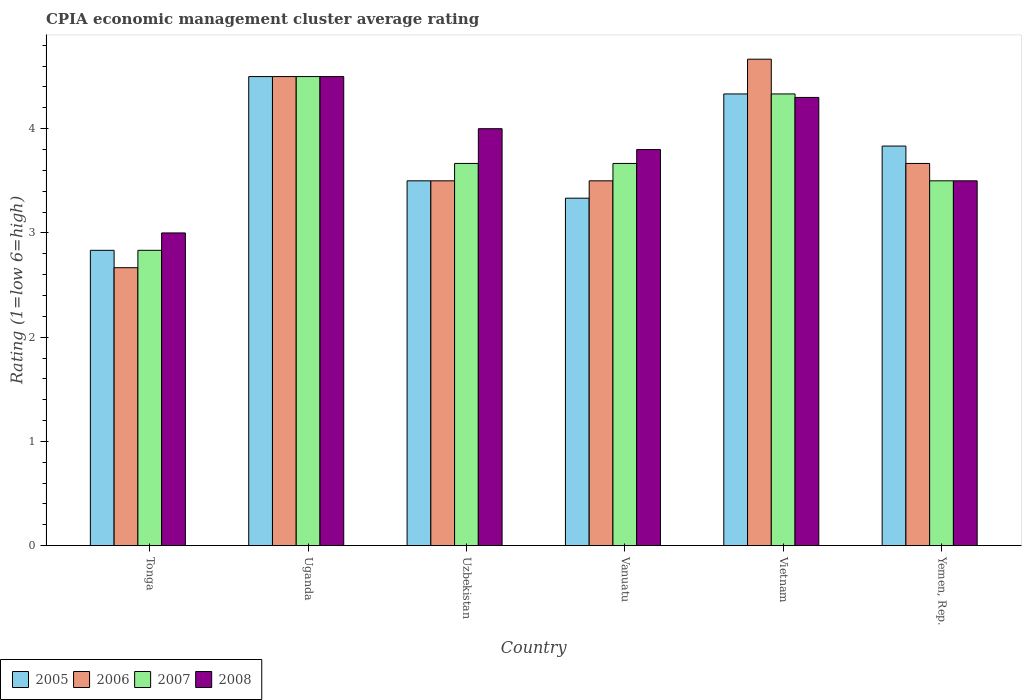How many different coloured bars are there?
Provide a short and direct response. 4. How many bars are there on the 5th tick from the left?
Ensure brevity in your answer.  4. What is the label of the 2nd group of bars from the left?
Provide a short and direct response. Uganda. In how many cases, is the number of bars for a given country not equal to the number of legend labels?
Keep it short and to the point. 0. What is the CPIA rating in 2006 in Tonga?
Ensure brevity in your answer.  2.67. Across all countries, what is the maximum CPIA rating in 2007?
Your answer should be compact. 4.5. Across all countries, what is the minimum CPIA rating in 2006?
Provide a short and direct response. 2.67. In which country was the CPIA rating in 2005 maximum?
Your answer should be compact. Uganda. In which country was the CPIA rating in 2006 minimum?
Keep it short and to the point. Tonga. What is the total CPIA rating in 2006 in the graph?
Your answer should be compact. 22.5. What is the difference between the CPIA rating in 2006 in Uzbekistan and that in Vietnam?
Keep it short and to the point. -1.17. What is the difference between the CPIA rating in 2008 in Vanuatu and the CPIA rating in 2006 in Yemen, Rep.?
Make the answer very short. 0.13. What is the average CPIA rating in 2008 per country?
Make the answer very short. 3.85. What is the difference between the CPIA rating of/in 2006 and CPIA rating of/in 2005 in Vietnam?
Offer a very short reply. 0.33. What is the ratio of the CPIA rating in 2008 in Tonga to that in Vietnam?
Provide a short and direct response. 0.7. Is the difference between the CPIA rating in 2006 in Tonga and Yemen, Rep. greater than the difference between the CPIA rating in 2005 in Tonga and Yemen, Rep.?
Ensure brevity in your answer.  No. In how many countries, is the CPIA rating in 2008 greater than the average CPIA rating in 2008 taken over all countries?
Ensure brevity in your answer.  3. Is it the case that in every country, the sum of the CPIA rating in 2007 and CPIA rating in 2008 is greater than the sum of CPIA rating in 2006 and CPIA rating in 2005?
Give a very brief answer. No. What does the 4th bar from the left in Vanuatu represents?
Your response must be concise. 2008. How many countries are there in the graph?
Offer a very short reply. 6. Are the values on the major ticks of Y-axis written in scientific E-notation?
Make the answer very short. No. Where does the legend appear in the graph?
Your answer should be very brief. Bottom left. How many legend labels are there?
Your response must be concise. 4. How are the legend labels stacked?
Provide a short and direct response. Horizontal. What is the title of the graph?
Provide a succinct answer. CPIA economic management cluster average rating. What is the label or title of the Y-axis?
Ensure brevity in your answer.  Rating (1=low 6=high). What is the Rating (1=low 6=high) of 2005 in Tonga?
Give a very brief answer. 2.83. What is the Rating (1=low 6=high) in 2006 in Tonga?
Your response must be concise. 2.67. What is the Rating (1=low 6=high) in 2007 in Tonga?
Make the answer very short. 2.83. What is the Rating (1=low 6=high) in 2008 in Tonga?
Offer a terse response. 3. What is the Rating (1=low 6=high) of 2006 in Uganda?
Ensure brevity in your answer.  4.5. What is the Rating (1=low 6=high) in 2007 in Uganda?
Your response must be concise. 4.5. What is the Rating (1=low 6=high) in 2007 in Uzbekistan?
Your answer should be compact. 3.67. What is the Rating (1=low 6=high) of 2008 in Uzbekistan?
Make the answer very short. 4. What is the Rating (1=low 6=high) in 2005 in Vanuatu?
Your answer should be very brief. 3.33. What is the Rating (1=low 6=high) of 2006 in Vanuatu?
Your answer should be very brief. 3.5. What is the Rating (1=low 6=high) in 2007 in Vanuatu?
Provide a short and direct response. 3.67. What is the Rating (1=low 6=high) of 2008 in Vanuatu?
Provide a succinct answer. 3.8. What is the Rating (1=low 6=high) of 2005 in Vietnam?
Your response must be concise. 4.33. What is the Rating (1=low 6=high) in 2006 in Vietnam?
Provide a succinct answer. 4.67. What is the Rating (1=low 6=high) of 2007 in Vietnam?
Your answer should be compact. 4.33. What is the Rating (1=low 6=high) of 2005 in Yemen, Rep.?
Your answer should be very brief. 3.83. What is the Rating (1=low 6=high) in 2006 in Yemen, Rep.?
Keep it short and to the point. 3.67. What is the Rating (1=low 6=high) of 2007 in Yemen, Rep.?
Provide a succinct answer. 3.5. What is the Rating (1=low 6=high) of 2008 in Yemen, Rep.?
Keep it short and to the point. 3.5. Across all countries, what is the maximum Rating (1=low 6=high) in 2005?
Offer a very short reply. 4.5. Across all countries, what is the maximum Rating (1=low 6=high) of 2006?
Make the answer very short. 4.67. Across all countries, what is the maximum Rating (1=low 6=high) in 2008?
Provide a short and direct response. 4.5. Across all countries, what is the minimum Rating (1=low 6=high) of 2005?
Your answer should be compact. 2.83. Across all countries, what is the minimum Rating (1=low 6=high) in 2006?
Offer a terse response. 2.67. Across all countries, what is the minimum Rating (1=low 6=high) in 2007?
Provide a short and direct response. 2.83. Across all countries, what is the minimum Rating (1=low 6=high) in 2008?
Give a very brief answer. 3. What is the total Rating (1=low 6=high) of 2005 in the graph?
Your answer should be compact. 22.33. What is the total Rating (1=low 6=high) of 2006 in the graph?
Provide a succinct answer. 22.5. What is the total Rating (1=low 6=high) in 2008 in the graph?
Keep it short and to the point. 23.1. What is the difference between the Rating (1=low 6=high) in 2005 in Tonga and that in Uganda?
Ensure brevity in your answer.  -1.67. What is the difference between the Rating (1=low 6=high) in 2006 in Tonga and that in Uganda?
Keep it short and to the point. -1.83. What is the difference between the Rating (1=low 6=high) in 2007 in Tonga and that in Uganda?
Your answer should be compact. -1.67. What is the difference between the Rating (1=low 6=high) of 2007 in Tonga and that in Uzbekistan?
Offer a very short reply. -0.83. What is the difference between the Rating (1=low 6=high) in 2008 in Tonga and that in Uzbekistan?
Your answer should be very brief. -1. What is the difference between the Rating (1=low 6=high) of 2007 in Tonga and that in Vanuatu?
Your response must be concise. -0.83. What is the difference between the Rating (1=low 6=high) in 2005 in Tonga and that in Vietnam?
Your answer should be very brief. -1.5. What is the difference between the Rating (1=low 6=high) of 2006 in Tonga and that in Vietnam?
Provide a short and direct response. -2. What is the difference between the Rating (1=low 6=high) of 2005 in Tonga and that in Yemen, Rep.?
Offer a very short reply. -1. What is the difference between the Rating (1=low 6=high) in 2006 in Tonga and that in Yemen, Rep.?
Your answer should be very brief. -1. What is the difference between the Rating (1=low 6=high) in 2007 in Tonga and that in Yemen, Rep.?
Ensure brevity in your answer.  -0.67. What is the difference between the Rating (1=low 6=high) in 2008 in Tonga and that in Yemen, Rep.?
Your answer should be compact. -0.5. What is the difference between the Rating (1=low 6=high) of 2008 in Uganda and that in Uzbekistan?
Give a very brief answer. 0.5. What is the difference between the Rating (1=low 6=high) in 2005 in Uganda and that in Vanuatu?
Your answer should be very brief. 1.17. What is the difference between the Rating (1=low 6=high) of 2006 in Uganda and that in Vanuatu?
Your response must be concise. 1. What is the difference between the Rating (1=low 6=high) of 2005 in Uganda and that in Vietnam?
Your response must be concise. 0.17. What is the difference between the Rating (1=low 6=high) of 2006 in Uganda and that in Vietnam?
Keep it short and to the point. -0.17. What is the difference between the Rating (1=low 6=high) of 2008 in Uganda and that in Vietnam?
Your answer should be very brief. 0.2. What is the difference between the Rating (1=low 6=high) of 2006 in Uganda and that in Yemen, Rep.?
Provide a short and direct response. 0.83. What is the difference between the Rating (1=low 6=high) in 2007 in Uganda and that in Yemen, Rep.?
Offer a very short reply. 1. What is the difference between the Rating (1=low 6=high) in 2008 in Uganda and that in Yemen, Rep.?
Your answer should be compact. 1. What is the difference between the Rating (1=low 6=high) of 2006 in Uzbekistan and that in Vanuatu?
Keep it short and to the point. 0. What is the difference between the Rating (1=low 6=high) of 2008 in Uzbekistan and that in Vanuatu?
Ensure brevity in your answer.  0.2. What is the difference between the Rating (1=low 6=high) of 2005 in Uzbekistan and that in Vietnam?
Your answer should be very brief. -0.83. What is the difference between the Rating (1=low 6=high) of 2006 in Uzbekistan and that in Vietnam?
Your answer should be compact. -1.17. What is the difference between the Rating (1=low 6=high) of 2007 in Uzbekistan and that in Vietnam?
Keep it short and to the point. -0.67. What is the difference between the Rating (1=low 6=high) in 2008 in Uzbekistan and that in Vietnam?
Offer a terse response. -0.3. What is the difference between the Rating (1=low 6=high) of 2006 in Uzbekistan and that in Yemen, Rep.?
Keep it short and to the point. -0.17. What is the difference between the Rating (1=low 6=high) of 2007 in Uzbekistan and that in Yemen, Rep.?
Offer a very short reply. 0.17. What is the difference between the Rating (1=low 6=high) of 2008 in Uzbekistan and that in Yemen, Rep.?
Provide a succinct answer. 0.5. What is the difference between the Rating (1=low 6=high) of 2006 in Vanuatu and that in Vietnam?
Your answer should be very brief. -1.17. What is the difference between the Rating (1=low 6=high) of 2007 in Vanuatu and that in Yemen, Rep.?
Give a very brief answer. 0.17. What is the difference between the Rating (1=low 6=high) of 2008 in Vanuatu and that in Yemen, Rep.?
Offer a terse response. 0.3. What is the difference between the Rating (1=low 6=high) of 2006 in Vietnam and that in Yemen, Rep.?
Offer a terse response. 1. What is the difference between the Rating (1=low 6=high) in 2005 in Tonga and the Rating (1=low 6=high) in 2006 in Uganda?
Keep it short and to the point. -1.67. What is the difference between the Rating (1=low 6=high) in 2005 in Tonga and the Rating (1=low 6=high) in 2007 in Uganda?
Give a very brief answer. -1.67. What is the difference between the Rating (1=low 6=high) of 2005 in Tonga and the Rating (1=low 6=high) of 2008 in Uganda?
Your answer should be very brief. -1.67. What is the difference between the Rating (1=low 6=high) of 2006 in Tonga and the Rating (1=low 6=high) of 2007 in Uganda?
Give a very brief answer. -1.83. What is the difference between the Rating (1=low 6=high) of 2006 in Tonga and the Rating (1=low 6=high) of 2008 in Uganda?
Your answer should be compact. -1.83. What is the difference between the Rating (1=low 6=high) of 2007 in Tonga and the Rating (1=low 6=high) of 2008 in Uganda?
Offer a terse response. -1.67. What is the difference between the Rating (1=low 6=high) of 2005 in Tonga and the Rating (1=low 6=high) of 2006 in Uzbekistan?
Ensure brevity in your answer.  -0.67. What is the difference between the Rating (1=low 6=high) of 2005 in Tonga and the Rating (1=low 6=high) of 2008 in Uzbekistan?
Your response must be concise. -1.17. What is the difference between the Rating (1=low 6=high) of 2006 in Tonga and the Rating (1=low 6=high) of 2008 in Uzbekistan?
Keep it short and to the point. -1.33. What is the difference between the Rating (1=low 6=high) of 2007 in Tonga and the Rating (1=low 6=high) of 2008 in Uzbekistan?
Your answer should be compact. -1.17. What is the difference between the Rating (1=low 6=high) of 2005 in Tonga and the Rating (1=low 6=high) of 2006 in Vanuatu?
Your answer should be very brief. -0.67. What is the difference between the Rating (1=low 6=high) of 2005 in Tonga and the Rating (1=low 6=high) of 2008 in Vanuatu?
Keep it short and to the point. -0.97. What is the difference between the Rating (1=low 6=high) of 2006 in Tonga and the Rating (1=low 6=high) of 2008 in Vanuatu?
Keep it short and to the point. -1.13. What is the difference between the Rating (1=low 6=high) in 2007 in Tonga and the Rating (1=low 6=high) in 2008 in Vanuatu?
Ensure brevity in your answer.  -0.97. What is the difference between the Rating (1=low 6=high) in 2005 in Tonga and the Rating (1=low 6=high) in 2006 in Vietnam?
Your answer should be very brief. -1.83. What is the difference between the Rating (1=low 6=high) of 2005 in Tonga and the Rating (1=low 6=high) of 2007 in Vietnam?
Your response must be concise. -1.5. What is the difference between the Rating (1=low 6=high) of 2005 in Tonga and the Rating (1=low 6=high) of 2008 in Vietnam?
Offer a terse response. -1.47. What is the difference between the Rating (1=low 6=high) of 2006 in Tonga and the Rating (1=low 6=high) of 2007 in Vietnam?
Offer a very short reply. -1.67. What is the difference between the Rating (1=low 6=high) in 2006 in Tonga and the Rating (1=low 6=high) in 2008 in Vietnam?
Offer a very short reply. -1.63. What is the difference between the Rating (1=low 6=high) of 2007 in Tonga and the Rating (1=low 6=high) of 2008 in Vietnam?
Keep it short and to the point. -1.47. What is the difference between the Rating (1=low 6=high) in 2005 in Tonga and the Rating (1=low 6=high) in 2007 in Yemen, Rep.?
Offer a very short reply. -0.67. What is the difference between the Rating (1=low 6=high) of 2006 in Tonga and the Rating (1=low 6=high) of 2007 in Yemen, Rep.?
Make the answer very short. -0.83. What is the difference between the Rating (1=low 6=high) of 2006 in Uganda and the Rating (1=low 6=high) of 2008 in Uzbekistan?
Ensure brevity in your answer.  0.5. What is the difference between the Rating (1=low 6=high) of 2007 in Uganda and the Rating (1=low 6=high) of 2008 in Uzbekistan?
Provide a succinct answer. 0.5. What is the difference between the Rating (1=low 6=high) in 2005 in Uganda and the Rating (1=low 6=high) in 2007 in Vanuatu?
Provide a succinct answer. 0.83. What is the difference between the Rating (1=low 6=high) in 2006 in Uganda and the Rating (1=low 6=high) in 2008 in Vanuatu?
Give a very brief answer. 0.7. What is the difference between the Rating (1=low 6=high) of 2007 in Uganda and the Rating (1=low 6=high) of 2008 in Vanuatu?
Provide a short and direct response. 0.7. What is the difference between the Rating (1=low 6=high) in 2005 in Uganda and the Rating (1=low 6=high) in 2006 in Vietnam?
Provide a short and direct response. -0.17. What is the difference between the Rating (1=low 6=high) in 2005 in Uganda and the Rating (1=low 6=high) in 2007 in Vietnam?
Offer a terse response. 0.17. What is the difference between the Rating (1=low 6=high) of 2005 in Uganda and the Rating (1=low 6=high) of 2008 in Vietnam?
Ensure brevity in your answer.  0.2. What is the difference between the Rating (1=low 6=high) in 2006 in Uganda and the Rating (1=low 6=high) in 2007 in Vietnam?
Give a very brief answer. 0.17. What is the difference between the Rating (1=low 6=high) in 2006 in Uganda and the Rating (1=low 6=high) in 2008 in Vietnam?
Make the answer very short. 0.2. What is the difference between the Rating (1=low 6=high) in 2007 in Uganda and the Rating (1=low 6=high) in 2008 in Vietnam?
Give a very brief answer. 0.2. What is the difference between the Rating (1=low 6=high) in 2005 in Uganda and the Rating (1=low 6=high) in 2007 in Yemen, Rep.?
Give a very brief answer. 1. What is the difference between the Rating (1=low 6=high) of 2007 in Uganda and the Rating (1=low 6=high) of 2008 in Yemen, Rep.?
Your answer should be very brief. 1. What is the difference between the Rating (1=low 6=high) of 2005 in Uzbekistan and the Rating (1=low 6=high) of 2006 in Vanuatu?
Offer a very short reply. 0. What is the difference between the Rating (1=low 6=high) in 2005 in Uzbekistan and the Rating (1=low 6=high) in 2008 in Vanuatu?
Provide a short and direct response. -0.3. What is the difference between the Rating (1=low 6=high) of 2006 in Uzbekistan and the Rating (1=low 6=high) of 2007 in Vanuatu?
Ensure brevity in your answer.  -0.17. What is the difference between the Rating (1=low 6=high) of 2007 in Uzbekistan and the Rating (1=low 6=high) of 2008 in Vanuatu?
Your answer should be compact. -0.13. What is the difference between the Rating (1=low 6=high) in 2005 in Uzbekistan and the Rating (1=low 6=high) in 2006 in Vietnam?
Keep it short and to the point. -1.17. What is the difference between the Rating (1=low 6=high) of 2005 in Uzbekistan and the Rating (1=low 6=high) of 2008 in Vietnam?
Give a very brief answer. -0.8. What is the difference between the Rating (1=low 6=high) of 2006 in Uzbekistan and the Rating (1=low 6=high) of 2007 in Vietnam?
Keep it short and to the point. -0.83. What is the difference between the Rating (1=low 6=high) of 2007 in Uzbekistan and the Rating (1=low 6=high) of 2008 in Vietnam?
Make the answer very short. -0.63. What is the difference between the Rating (1=low 6=high) in 2005 in Uzbekistan and the Rating (1=low 6=high) in 2006 in Yemen, Rep.?
Offer a terse response. -0.17. What is the difference between the Rating (1=low 6=high) in 2005 in Uzbekistan and the Rating (1=low 6=high) in 2008 in Yemen, Rep.?
Keep it short and to the point. 0. What is the difference between the Rating (1=low 6=high) in 2006 in Uzbekistan and the Rating (1=low 6=high) in 2008 in Yemen, Rep.?
Provide a short and direct response. 0. What is the difference between the Rating (1=low 6=high) of 2007 in Uzbekistan and the Rating (1=low 6=high) of 2008 in Yemen, Rep.?
Your response must be concise. 0.17. What is the difference between the Rating (1=low 6=high) in 2005 in Vanuatu and the Rating (1=low 6=high) in 2006 in Vietnam?
Your answer should be very brief. -1.33. What is the difference between the Rating (1=low 6=high) of 2005 in Vanuatu and the Rating (1=low 6=high) of 2007 in Vietnam?
Offer a terse response. -1. What is the difference between the Rating (1=low 6=high) in 2005 in Vanuatu and the Rating (1=low 6=high) in 2008 in Vietnam?
Your answer should be very brief. -0.97. What is the difference between the Rating (1=low 6=high) in 2006 in Vanuatu and the Rating (1=low 6=high) in 2007 in Vietnam?
Your answer should be very brief. -0.83. What is the difference between the Rating (1=low 6=high) in 2006 in Vanuatu and the Rating (1=low 6=high) in 2008 in Vietnam?
Your response must be concise. -0.8. What is the difference between the Rating (1=low 6=high) of 2007 in Vanuatu and the Rating (1=low 6=high) of 2008 in Vietnam?
Your answer should be very brief. -0.63. What is the difference between the Rating (1=low 6=high) in 2005 in Vanuatu and the Rating (1=low 6=high) in 2006 in Yemen, Rep.?
Make the answer very short. -0.33. What is the difference between the Rating (1=low 6=high) of 2005 in Vanuatu and the Rating (1=low 6=high) of 2008 in Yemen, Rep.?
Your response must be concise. -0.17. What is the difference between the Rating (1=low 6=high) in 2006 in Vanuatu and the Rating (1=low 6=high) in 2007 in Yemen, Rep.?
Make the answer very short. 0. What is the difference between the Rating (1=low 6=high) in 2006 in Vanuatu and the Rating (1=low 6=high) in 2008 in Yemen, Rep.?
Provide a short and direct response. 0. What is the difference between the Rating (1=low 6=high) in 2007 in Vanuatu and the Rating (1=low 6=high) in 2008 in Yemen, Rep.?
Provide a succinct answer. 0.17. What is the difference between the Rating (1=low 6=high) in 2006 in Vietnam and the Rating (1=low 6=high) in 2007 in Yemen, Rep.?
Ensure brevity in your answer.  1.17. What is the difference between the Rating (1=low 6=high) of 2006 in Vietnam and the Rating (1=low 6=high) of 2008 in Yemen, Rep.?
Offer a terse response. 1.17. What is the difference between the Rating (1=low 6=high) in 2007 in Vietnam and the Rating (1=low 6=high) in 2008 in Yemen, Rep.?
Your answer should be compact. 0.83. What is the average Rating (1=low 6=high) of 2005 per country?
Your answer should be very brief. 3.72. What is the average Rating (1=low 6=high) in 2006 per country?
Your response must be concise. 3.75. What is the average Rating (1=low 6=high) in 2007 per country?
Provide a short and direct response. 3.75. What is the average Rating (1=low 6=high) of 2008 per country?
Ensure brevity in your answer.  3.85. What is the difference between the Rating (1=low 6=high) of 2006 and Rating (1=low 6=high) of 2007 in Tonga?
Your answer should be very brief. -0.17. What is the difference between the Rating (1=low 6=high) in 2006 and Rating (1=low 6=high) in 2008 in Tonga?
Your response must be concise. -0.33. What is the difference between the Rating (1=low 6=high) of 2005 and Rating (1=low 6=high) of 2008 in Uganda?
Your answer should be very brief. 0. What is the difference between the Rating (1=low 6=high) of 2006 and Rating (1=low 6=high) of 2007 in Uganda?
Provide a succinct answer. 0. What is the difference between the Rating (1=low 6=high) in 2007 and Rating (1=low 6=high) in 2008 in Uganda?
Provide a short and direct response. 0. What is the difference between the Rating (1=low 6=high) in 2005 and Rating (1=low 6=high) in 2006 in Uzbekistan?
Provide a succinct answer. 0. What is the difference between the Rating (1=low 6=high) of 2005 and Rating (1=low 6=high) of 2007 in Uzbekistan?
Offer a very short reply. -0.17. What is the difference between the Rating (1=low 6=high) in 2005 and Rating (1=low 6=high) in 2008 in Uzbekistan?
Your response must be concise. -0.5. What is the difference between the Rating (1=low 6=high) in 2006 and Rating (1=low 6=high) in 2007 in Uzbekistan?
Provide a succinct answer. -0.17. What is the difference between the Rating (1=low 6=high) of 2006 and Rating (1=low 6=high) of 2008 in Uzbekistan?
Offer a terse response. -0.5. What is the difference between the Rating (1=low 6=high) of 2007 and Rating (1=low 6=high) of 2008 in Uzbekistan?
Offer a terse response. -0.33. What is the difference between the Rating (1=low 6=high) of 2005 and Rating (1=low 6=high) of 2006 in Vanuatu?
Your answer should be compact. -0.17. What is the difference between the Rating (1=low 6=high) in 2005 and Rating (1=low 6=high) in 2007 in Vanuatu?
Provide a succinct answer. -0.33. What is the difference between the Rating (1=low 6=high) in 2005 and Rating (1=low 6=high) in 2008 in Vanuatu?
Give a very brief answer. -0.47. What is the difference between the Rating (1=low 6=high) of 2006 and Rating (1=low 6=high) of 2008 in Vanuatu?
Offer a terse response. -0.3. What is the difference between the Rating (1=low 6=high) of 2007 and Rating (1=low 6=high) of 2008 in Vanuatu?
Your answer should be very brief. -0.13. What is the difference between the Rating (1=low 6=high) in 2005 and Rating (1=low 6=high) in 2006 in Vietnam?
Keep it short and to the point. -0.33. What is the difference between the Rating (1=low 6=high) of 2005 and Rating (1=low 6=high) of 2008 in Vietnam?
Keep it short and to the point. 0.03. What is the difference between the Rating (1=low 6=high) in 2006 and Rating (1=low 6=high) in 2007 in Vietnam?
Your answer should be very brief. 0.33. What is the difference between the Rating (1=low 6=high) of 2006 and Rating (1=low 6=high) of 2008 in Vietnam?
Your answer should be compact. 0.37. What is the difference between the Rating (1=low 6=high) in 2005 and Rating (1=low 6=high) in 2008 in Yemen, Rep.?
Offer a terse response. 0.33. What is the difference between the Rating (1=low 6=high) in 2006 and Rating (1=low 6=high) in 2007 in Yemen, Rep.?
Provide a short and direct response. 0.17. What is the difference between the Rating (1=low 6=high) in 2007 and Rating (1=low 6=high) in 2008 in Yemen, Rep.?
Your answer should be very brief. 0. What is the ratio of the Rating (1=low 6=high) of 2005 in Tonga to that in Uganda?
Offer a very short reply. 0.63. What is the ratio of the Rating (1=low 6=high) of 2006 in Tonga to that in Uganda?
Provide a short and direct response. 0.59. What is the ratio of the Rating (1=low 6=high) of 2007 in Tonga to that in Uganda?
Offer a terse response. 0.63. What is the ratio of the Rating (1=low 6=high) of 2005 in Tonga to that in Uzbekistan?
Your response must be concise. 0.81. What is the ratio of the Rating (1=low 6=high) in 2006 in Tonga to that in Uzbekistan?
Ensure brevity in your answer.  0.76. What is the ratio of the Rating (1=low 6=high) of 2007 in Tonga to that in Uzbekistan?
Offer a terse response. 0.77. What is the ratio of the Rating (1=low 6=high) of 2008 in Tonga to that in Uzbekistan?
Make the answer very short. 0.75. What is the ratio of the Rating (1=low 6=high) of 2005 in Tonga to that in Vanuatu?
Provide a short and direct response. 0.85. What is the ratio of the Rating (1=low 6=high) in 2006 in Tonga to that in Vanuatu?
Your response must be concise. 0.76. What is the ratio of the Rating (1=low 6=high) in 2007 in Tonga to that in Vanuatu?
Keep it short and to the point. 0.77. What is the ratio of the Rating (1=low 6=high) of 2008 in Tonga to that in Vanuatu?
Your answer should be very brief. 0.79. What is the ratio of the Rating (1=low 6=high) in 2005 in Tonga to that in Vietnam?
Your answer should be compact. 0.65. What is the ratio of the Rating (1=low 6=high) in 2007 in Tonga to that in Vietnam?
Make the answer very short. 0.65. What is the ratio of the Rating (1=low 6=high) of 2008 in Tonga to that in Vietnam?
Ensure brevity in your answer.  0.7. What is the ratio of the Rating (1=low 6=high) in 2005 in Tonga to that in Yemen, Rep.?
Ensure brevity in your answer.  0.74. What is the ratio of the Rating (1=low 6=high) in 2006 in Tonga to that in Yemen, Rep.?
Your answer should be very brief. 0.73. What is the ratio of the Rating (1=low 6=high) in 2007 in Tonga to that in Yemen, Rep.?
Make the answer very short. 0.81. What is the ratio of the Rating (1=low 6=high) in 2005 in Uganda to that in Uzbekistan?
Keep it short and to the point. 1.29. What is the ratio of the Rating (1=low 6=high) in 2006 in Uganda to that in Uzbekistan?
Provide a short and direct response. 1.29. What is the ratio of the Rating (1=low 6=high) in 2007 in Uganda to that in Uzbekistan?
Offer a very short reply. 1.23. What is the ratio of the Rating (1=low 6=high) in 2005 in Uganda to that in Vanuatu?
Ensure brevity in your answer.  1.35. What is the ratio of the Rating (1=low 6=high) of 2006 in Uganda to that in Vanuatu?
Ensure brevity in your answer.  1.29. What is the ratio of the Rating (1=low 6=high) in 2007 in Uganda to that in Vanuatu?
Your answer should be very brief. 1.23. What is the ratio of the Rating (1=low 6=high) in 2008 in Uganda to that in Vanuatu?
Give a very brief answer. 1.18. What is the ratio of the Rating (1=low 6=high) in 2005 in Uganda to that in Vietnam?
Ensure brevity in your answer.  1.04. What is the ratio of the Rating (1=low 6=high) of 2006 in Uganda to that in Vietnam?
Offer a very short reply. 0.96. What is the ratio of the Rating (1=low 6=high) in 2008 in Uganda to that in Vietnam?
Your answer should be compact. 1.05. What is the ratio of the Rating (1=low 6=high) of 2005 in Uganda to that in Yemen, Rep.?
Offer a very short reply. 1.17. What is the ratio of the Rating (1=low 6=high) of 2006 in Uganda to that in Yemen, Rep.?
Keep it short and to the point. 1.23. What is the ratio of the Rating (1=low 6=high) of 2008 in Uganda to that in Yemen, Rep.?
Your response must be concise. 1.29. What is the ratio of the Rating (1=low 6=high) of 2005 in Uzbekistan to that in Vanuatu?
Provide a succinct answer. 1.05. What is the ratio of the Rating (1=low 6=high) in 2008 in Uzbekistan to that in Vanuatu?
Offer a terse response. 1.05. What is the ratio of the Rating (1=low 6=high) of 2005 in Uzbekistan to that in Vietnam?
Give a very brief answer. 0.81. What is the ratio of the Rating (1=low 6=high) of 2006 in Uzbekistan to that in Vietnam?
Ensure brevity in your answer.  0.75. What is the ratio of the Rating (1=low 6=high) in 2007 in Uzbekistan to that in Vietnam?
Make the answer very short. 0.85. What is the ratio of the Rating (1=low 6=high) of 2008 in Uzbekistan to that in Vietnam?
Ensure brevity in your answer.  0.93. What is the ratio of the Rating (1=low 6=high) of 2005 in Uzbekistan to that in Yemen, Rep.?
Your answer should be compact. 0.91. What is the ratio of the Rating (1=low 6=high) of 2006 in Uzbekistan to that in Yemen, Rep.?
Give a very brief answer. 0.95. What is the ratio of the Rating (1=low 6=high) in 2007 in Uzbekistan to that in Yemen, Rep.?
Ensure brevity in your answer.  1.05. What is the ratio of the Rating (1=low 6=high) in 2008 in Uzbekistan to that in Yemen, Rep.?
Offer a very short reply. 1.14. What is the ratio of the Rating (1=low 6=high) of 2005 in Vanuatu to that in Vietnam?
Provide a short and direct response. 0.77. What is the ratio of the Rating (1=low 6=high) of 2006 in Vanuatu to that in Vietnam?
Your answer should be very brief. 0.75. What is the ratio of the Rating (1=low 6=high) in 2007 in Vanuatu to that in Vietnam?
Your answer should be very brief. 0.85. What is the ratio of the Rating (1=low 6=high) in 2008 in Vanuatu to that in Vietnam?
Ensure brevity in your answer.  0.88. What is the ratio of the Rating (1=low 6=high) in 2005 in Vanuatu to that in Yemen, Rep.?
Keep it short and to the point. 0.87. What is the ratio of the Rating (1=low 6=high) in 2006 in Vanuatu to that in Yemen, Rep.?
Your answer should be compact. 0.95. What is the ratio of the Rating (1=low 6=high) in 2007 in Vanuatu to that in Yemen, Rep.?
Make the answer very short. 1.05. What is the ratio of the Rating (1=low 6=high) of 2008 in Vanuatu to that in Yemen, Rep.?
Ensure brevity in your answer.  1.09. What is the ratio of the Rating (1=low 6=high) of 2005 in Vietnam to that in Yemen, Rep.?
Offer a very short reply. 1.13. What is the ratio of the Rating (1=low 6=high) in 2006 in Vietnam to that in Yemen, Rep.?
Ensure brevity in your answer.  1.27. What is the ratio of the Rating (1=low 6=high) in 2007 in Vietnam to that in Yemen, Rep.?
Your response must be concise. 1.24. What is the ratio of the Rating (1=low 6=high) in 2008 in Vietnam to that in Yemen, Rep.?
Your answer should be very brief. 1.23. What is the difference between the highest and the second highest Rating (1=low 6=high) of 2005?
Provide a succinct answer. 0.17. What is the difference between the highest and the second highest Rating (1=low 6=high) in 2007?
Keep it short and to the point. 0.17. What is the difference between the highest and the second highest Rating (1=low 6=high) in 2008?
Provide a short and direct response. 0.2. What is the difference between the highest and the lowest Rating (1=low 6=high) of 2005?
Offer a terse response. 1.67. What is the difference between the highest and the lowest Rating (1=low 6=high) of 2006?
Offer a very short reply. 2. What is the difference between the highest and the lowest Rating (1=low 6=high) of 2008?
Provide a short and direct response. 1.5. 